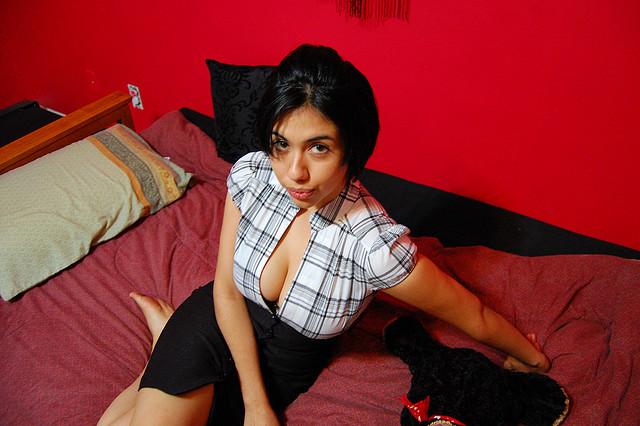Is the person wearing a modest clothing?
Give a very brief answer. No. What is the color of the room?
Concise answer only. Red. Can you see her belly button?
Quick response, please. No. Does the woman have long hair?
Give a very brief answer. No. What colors are the sheets?
Be succinct. Red. Is the girl wearing earrings?
Give a very brief answer. No. What color is the girls shirt?
Short answer required. White. 